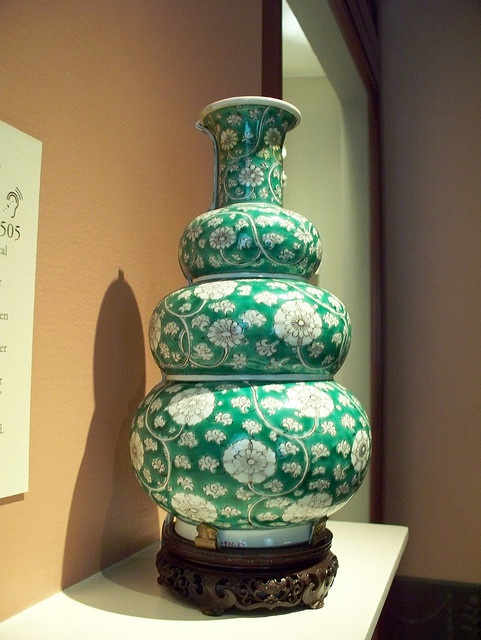Describe the objects in this image and their specific colors. I can see a vase in brown, darkgreen, and beige tones in this image. 